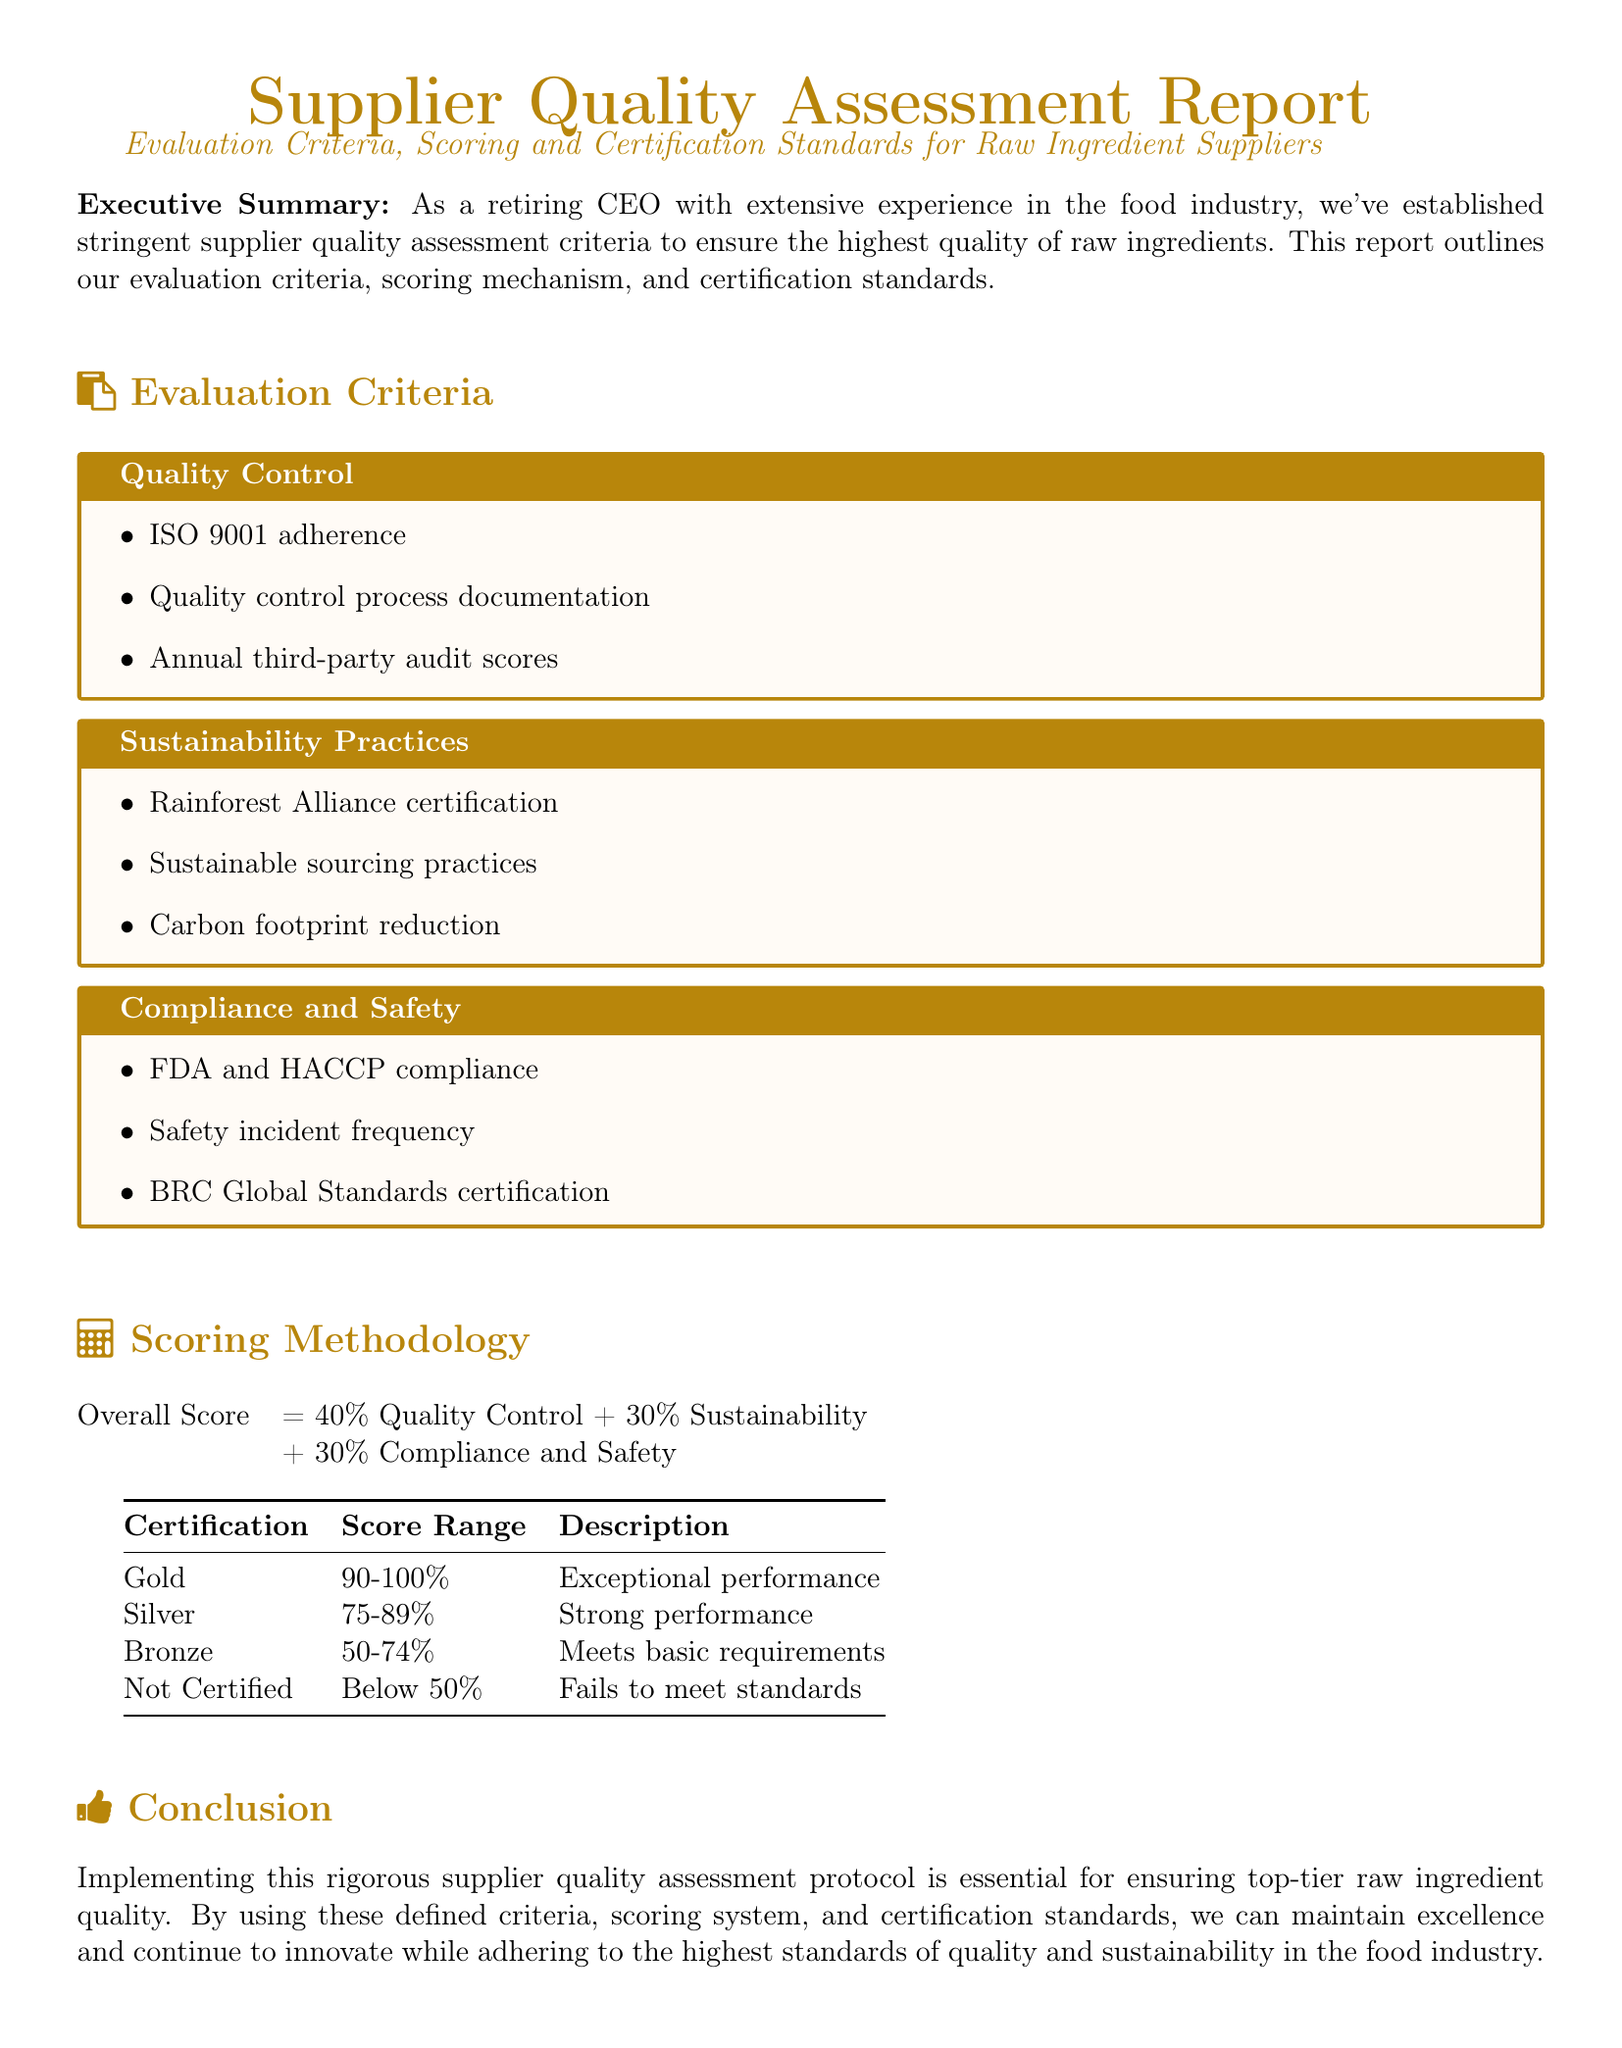What is the title of the document? The title of the document is the main heading presented at the top, providing the topic of the content, which is "Supplier Quality Assessment Report".
Answer: Supplier Quality Assessment Report What percentage of the overall score is attributed to Quality Control? The overall score distribution is given in the scoring methodology section, where Quality Control specifically accounts for 40% of the total score.
Answer: 40% Which certification corresponds to a score range of 75-89%? The certification table outlines the score ranges and their corresponding certifications, with the Silver certification falling within the 75-89% range.
Answer: Silver What is one of the sustainability practices assessed? The evaluation criteria for sustainability practices includes specific standards, with the Rainforest Alliance certification mentioned as a practice.
Answer: Rainforest Alliance certification What does an overall score below 50% indicate? The certification table clarifies that a score below 50% results in the status of "Not Certified," indicating failure to meet standards.
Answer: Not Certified Which safety standard does the document mention regarding compliance? The compliance and safety criteria clearly state adherence to various regulations, particularly the FDA and HACCP compliance as a standard.
Answer: FDA and HACCP compliance What is the main focus of the Executive Summary? The Executive Summary summarizes the purpose of the report, emphasizing established supplier quality assessment criteria for high-quality raw ingredients.
Answer: Supplier quality assessment criteria How many categories are included in the evaluation criteria? The document explicitly details the evaluation criteria, which includes three main categories: Quality Control, Sustainability Practices, and Compliance and Safety.
Answer: Three 